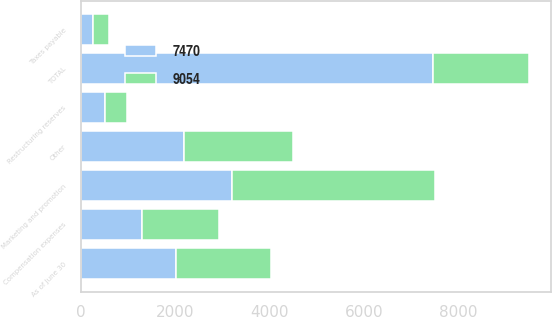Convert chart to OTSL. <chart><loc_0><loc_0><loc_500><loc_500><stacked_bar_chart><ecel><fcel>As of June 30<fcel>Marketing and promotion<fcel>Compensation expenses<fcel>Restructuring reserves<fcel>Taxes payable<fcel>Other<fcel>TOTAL<nl><fcel>9054<fcel>2019<fcel>4299<fcel>1623<fcel>468<fcel>341<fcel>2323<fcel>2018<nl><fcel>7470<fcel>2018<fcel>3208<fcel>1298<fcel>513<fcel>268<fcel>2183<fcel>7470<nl></chart> 